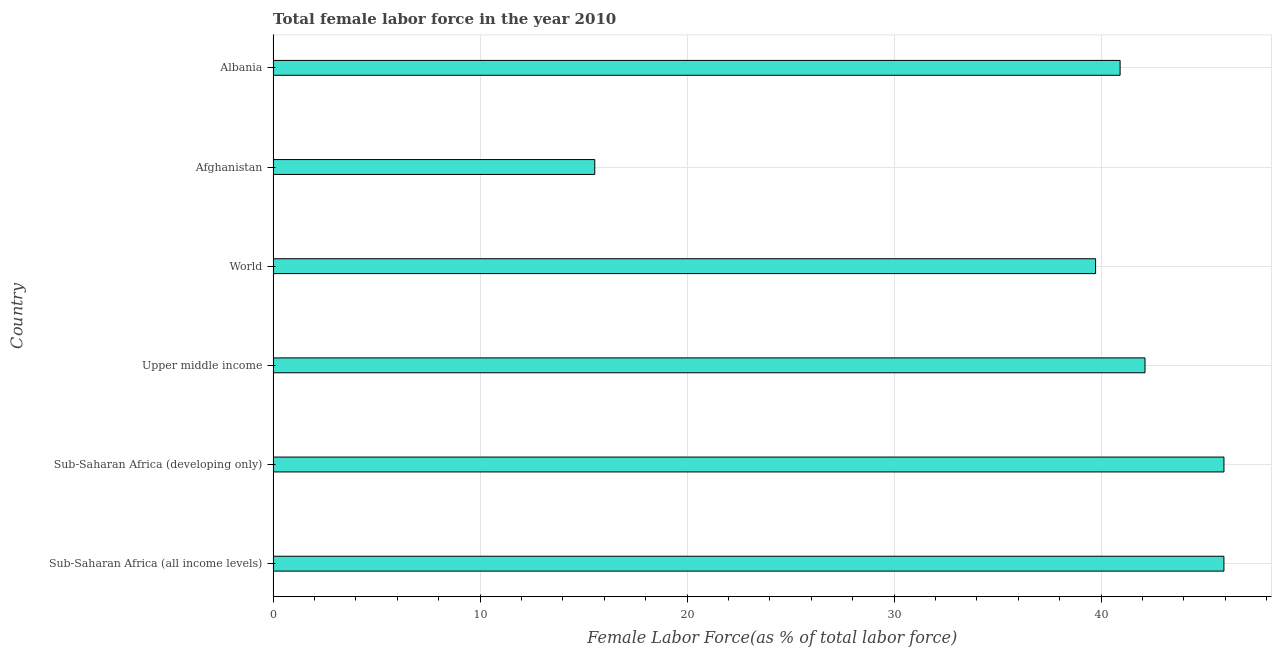Does the graph contain grids?
Offer a very short reply. Yes. What is the title of the graph?
Give a very brief answer. Total female labor force in the year 2010. What is the label or title of the X-axis?
Ensure brevity in your answer.  Female Labor Force(as % of total labor force). What is the total female labor force in Sub-Saharan Africa (developing only)?
Your response must be concise. 45.93. Across all countries, what is the maximum total female labor force?
Your answer should be very brief. 45.93. Across all countries, what is the minimum total female labor force?
Offer a terse response. 15.54. In which country was the total female labor force maximum?
Your answer should be compact. Sub-Saharan Africa (developing only). In which country was the total female labor force minimum?
Make the answer very short. Afghanistan. What is the sum of the total female labor force?
Your answer should be compact. 230.17. What is the difference between the total female labor force in Afghanistan and Sub-Saharan Africa (developing only)?
Give a very brief answer. -30.4. What is the average total female labor force per country?
Ensure brevity in your answer.  38.36. What is the median total female labor force?
Give a very brief answer. 41.52. In how many countries, is the total female labor force greater than 14 %?
Ensure brevity in your answer.  6. What is the ratio of the total female labor force in Sub-Saharan Africa (all income levels) to that in World?
Keep it short and to the point. 1.16. What is the difference between the highest and the second highest total female labor force?
Offer a very short reply. 0. Is the sum of the total female labor force in Upper middle income and World greater than the maximum total female labor force across all countries?
Make the answer very short. Yes. What is the difference between the highest and the lowest total female labor force?
Make the answer very short. 30.4. In how many countries, is the total female labor force greater than the average total female labor force taken over all countries?
Give a very brief answer. 5. What is the difference between two consecutive major ticks on the X-axis?
Give a very brief answer. 10. What is the Female Labor Force(as % of total labor force) of Sub-Saharan Africa (all income levels)?
Your answer should be very brief. 45.93. What is the Female Labor Force(as % of total labor force) in Sub-Saharan Africa (developing only)?
Offer a very short reply. 45.93. What is the Female Labor Force(as % of total labor force) in Upper middle income?
Your answer should be very brief. 42.12. What is the Female Labor Force(as % of total labor force) of World?
Offer a very short reply. 39.73. What is the Female Labor Force(as % of total labor force) in Afghanistan?
Provide a succinct answer. 15.54. What is the Female Labor Force(as % of total labor force) of Albania?
Give a very brief answer. 40.92. What is the difference between the Female Labor Force(as % of total labor force) in Sub-Saharan Africa (all income levels) and Sub-Saharan Africa (developing only)?
Ensure brevity in your answer.  -0. What is the difference between the Female Labor Force(as % of total labor force) in Sub-Saharan Africa (all income levels) and Upper middle income?
Provide a succinct answer. 3.81. What is the difference between the Female Labor Force(as % of total labor force) in Sub-Saharan Africa (all income levels) and World?
Provide a short and direct response. 6.2. What is the difference between the Female Labor Force(as % of total labor force) in Sub-Saharan Africa (all income levels) and Afghanistan?
Make the answer very short. 30.39. What is the difference between the Female Labor Force(as % of total labor force) in Sub-Saharan Africa (all income levels) and Albania?
Ensure brevity in your answer.  5.02. What is the difference between the Female Labor Force(as % of total labor force) in Sub-Saharan Africa (developing only) and Upper middle income?
Provide a short and direct response. 3.81. What is the difference between the Female Labor Force(as % of total labor force) in Sub-Saharan Africa (developing only) and World?
Your response must be concise. 6.2. What is the difference between the Female Labor Force(as % of total labor force) in Sub-Saharan Africa (developing only) and Afghanistan?
Your answer should be compact. 30.4. What is the difference between the Female Labor Force(as % of total labor force) in Sub-Saharan Africa (developing only) and Albania?
Offer a very short reply. 5.02. What is the difference between the Female Labor Force(as % of total labor force) in Upper middle income and World?
Provide a short and direct response. 2.39. What is the difference between the Female Labor Force(as % of total labor force) in Upper middle income and Afghanistan?
Your answer should be very brief. 26.58. What is the difference between the Female Labor Force(as % of total labor force) in Upper middle income and Albania?
Ensure brevity in your answer.  1.2. What is the difference between the Female Labor Force(as % of total labor force) in World and Afghanistan?
Give a very brief answer. 24.19. What is the difference between the Female Labor Force(as % of total labor force) in World and Albania?
Your answer should be very brief. -1.18. What is the difference between the Female Labor Force(as % of total labor force) in Afghanistan and Albania?
Keep it short and to the point. -25.38. What is the ratio of the Female Labor Force(as % of total labor force) in Sub-Saharan Africa (all income levels) to that in Upper middle income?
Provide a short and direct response. 1.09. What is the ratio of the Female Labor Force(as % of total labor force) in Sub-Saharan Africa (all income levels) to that in World?
Keep it short and to the point. 1.16. What is the ratio of the Female Labor Force(as % of total labor force) in Sub-Saharan Africa (all income levels) to that in Afghanistan?
Your answer should be very brief. 2.96. What is the ratio of the Female Labor Force(as % of total labor force) in Sub-Saharan Africa (all income levels) to that in Albania?
Your response must be concise. 1.12. What is the ratio of the Female Labor Force(as % of total labor force) in Sub-Saharan Africa (developing only) to that in Upper middle income?
Offer a very short reply. 1.09. What is the ratio of the Female Labor Force(as % of total labor force) in Sub-Saharan Africa (developing only) to that in World?
Give a very brief answer. 1.16. What is the ratio of the Female Labor Force(as % of total labor force) in Sub-Saharan Africa (developing only) to that in Afghanistan?
Give a very brief answer. 2.96. What is the ratio of the Female Labor Force(as % of total labor force) in Sub-Saharan Africa (developing only) to that in Albania?
Give a very brief answer. 1.12. What is the ratio of the Female Labor Force(as % of total labor force) in Upper middle income to that in World?
Your response must be concise. 1.06. What is the ratio of the Female Labor Force(as % of total labor force) in Upper middle income to that in Afghanistan?
Your response must be concise. 2.71. What is the ratio of the Female Labor Force(as % of total labor force) in Upper middle income to that in Albania?
Keep it short and to the point. 1.03. What is the ratio of the Female Labor Force(as % of total labor force) in World to that in Afghanistan?
Give a very brief answer. 2.56. What is the ratio of the Female Labor Force(as % of total labor force) in Afghanistan to that in Albania?
Make the answer very short. 0.38. 